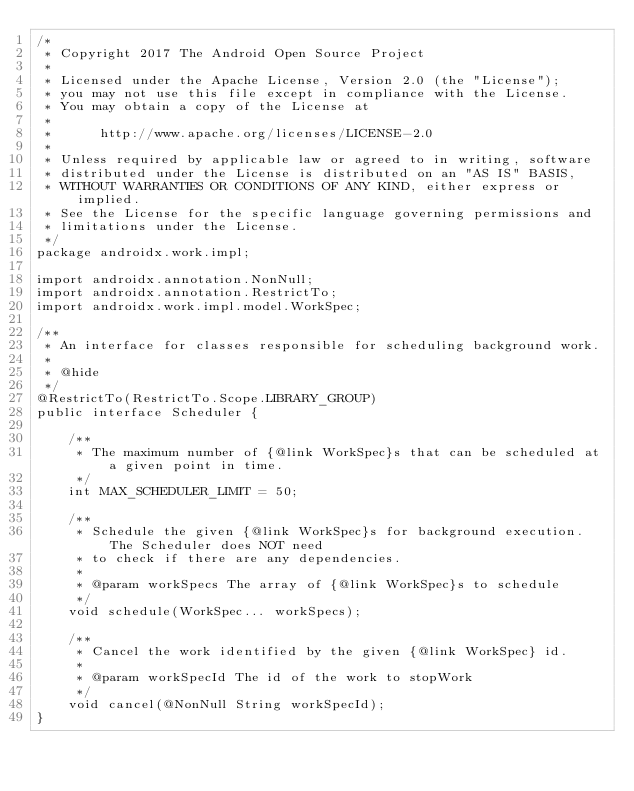Convert code to text. <code><loc_0><loc_0><loc_500><loc_500><_Java_>/*
 * Copyright 2017 The Android Open Source Project
 *
 * Licensed under the Apache License, Version 2.0 (the "License");
 * you may not use this file except in compliance with the License.
 * You may obtain a copy of the License at
 *
 *      http://www.apache.org/licenses/LICENSE-2.0
 *
 * Unless required by applicable law or agreed to in writing, software
 * distributed under the License is distributed on an "AS IS" BASIS,
 * WITHOUT WARRANTIES OR CONDITIONS OF ANY KIND, either express or implied.
 * See the License for the specific language governing permissions and
 * limitations under the License.
 */
package androidx.work.impl;

import androidx.annotation.NonNull;
import androidx.annotation.RestrictTo;
import androidx.work.impl.model.WorkSpec;

/**
 * An interface for classes responsible for scheduling background work.
 *
 * @hide
 */
@RestrictTo(RestrictTo.Scope.LIBRARY_GROUP)
public interface Scheduler {

    /**
     * The maximum number of {@link WorkSpec}s that can be scheduled at a given point in time.
     */
    int MAX_SCHEDULER_LIMIT = 50;

    /**
     * Schedule the given {@link WorkSpec}s for background execution.  The Scheduler does NOT need
     * to check if there are any dependencies.
     *
     * @param workSpecs The array of {@link WorkSpec}s to schedule
     */
    void schedule(WorkSpec... workSpecs);

    /**
     * Cancel the work identified by the given {@link WorkSpec} id.
     *
     * @param workSpecId The id of the work to stopWork
     */
    void cancel(@NonNull String workSpecId);
}
</code> 